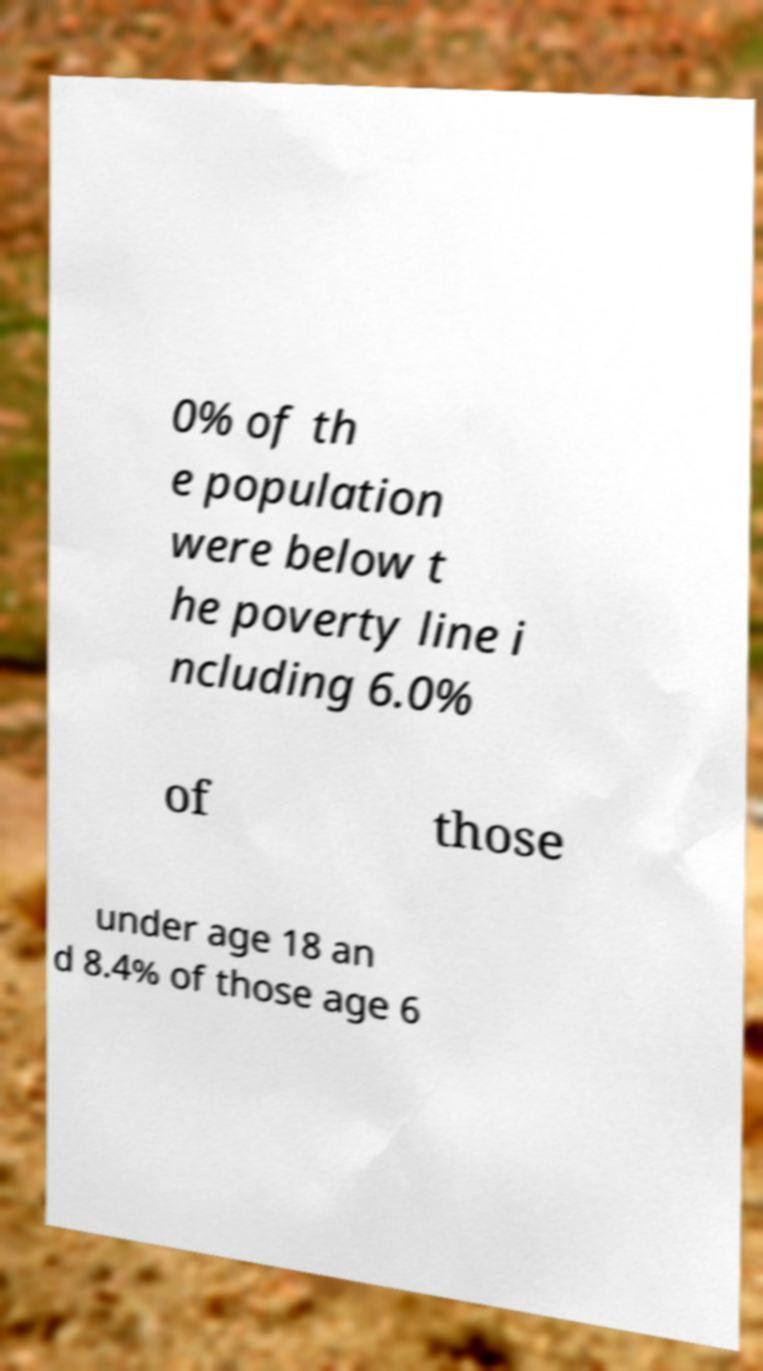There's text embedded in this image that I need extracted. Can you transcribe it verbatim? 0% of th e population were below t he poverty line i ncluding 6.0% of those under age 18 an d 8.4% of those age 6 